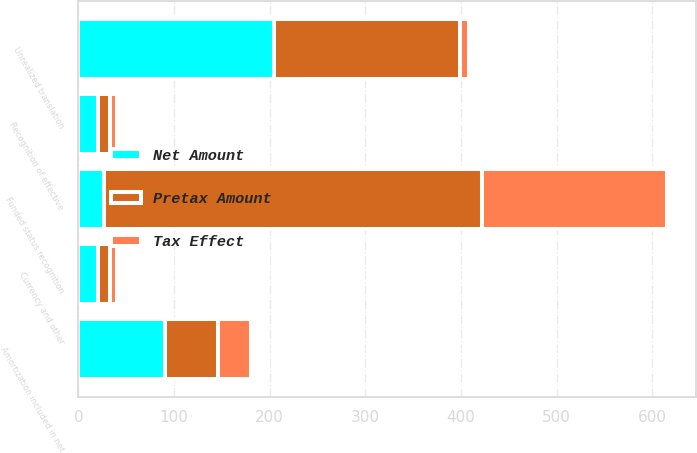Convert chart to OTSL. <chart><loc_0><loc_0><loc_500><loc_500><stacked_bar_chart><ecel><fcel>Unrealized translation<fcel>Funded status recognition<fcel>Amortization included in net<fcel>Currency and other<fcel>Recognition of effective<nl><fcel>Net Amount<fcel>204<fcel>27<fcel>90<fcel>20<fcel>20<nl><fcel>Tax Effect<fcel>9<fcel>193<fcel>34<fcel>7<fcel>7<nl><fcel>Pretax Amount<fcel>195<fcel>395<fcel>56<fcel>13<fcel>13<nl></chart> 